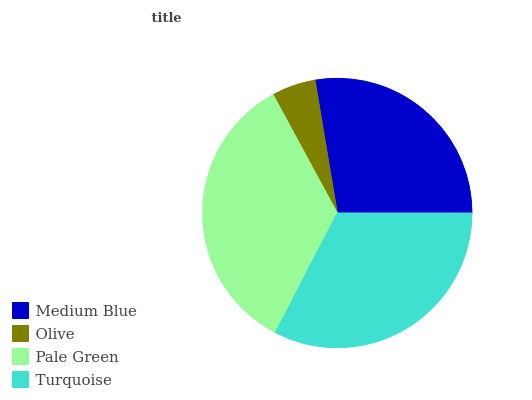Is Olive the minimum?
Answer yes or no. Yes. Is Pale Green the maximum?
Answer yes or no. Yes. Is Pale Green the minimum?
Answer yes or no. No. Is Olive the maximum?
Answer yes or no. No. Is Pale Green greater than Olive?
Answer yes or no. Yes. Is Olive less than Pale Green?
Answer yes or no. Yes. Is Olive greater than Pale Green?
Answer yes or no. No. Is Pale Green less than Olive?
Answer yes or no. No. Is Turquoise the high median?
Answer yes or no. Yes. Is Medium Blue the low median?
Answer yes or no. Yes. Is Olive the high median?
Answer yes or no. No. Is Olive the low median?
Answer yes or no. No. 